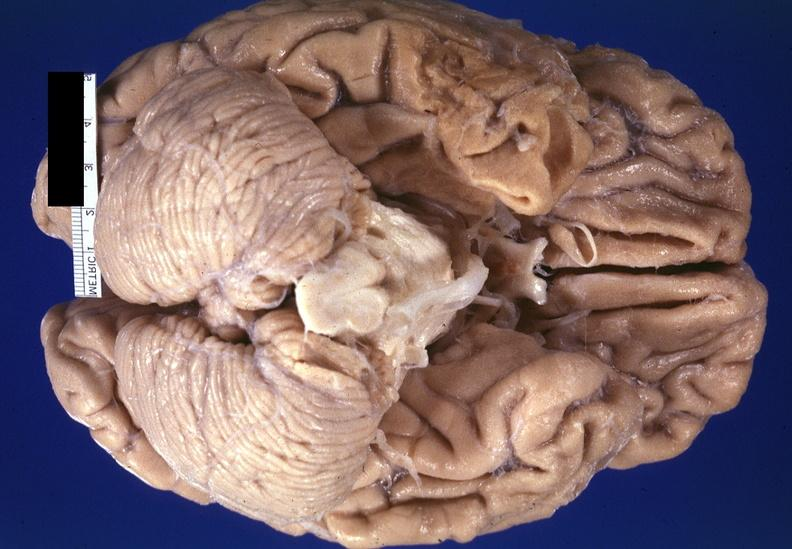s thymus present?
Answer the question using a single word or phrase. No 